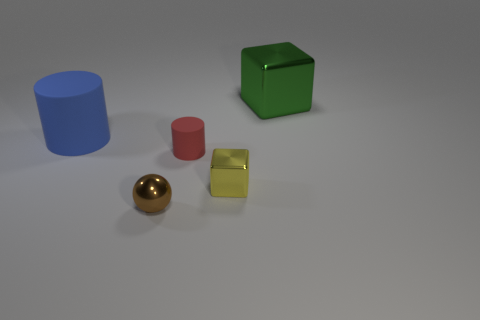There is a small thing that is the same shape as the large metallic thing; what color is it?
Offer a terse response. Yellow. What color is the metal block that is the same size as the red cylinder?
Your answer should be compact. Yellow. Are there an equal number of green blocks in front of the tiny block and tiny brown metallic spheres that are left of the tiny brown metallic thing?
Ensure brevity in your answer.  Yes. How many brown spheres have the same size as the red object?
Your answer should be very brief. 1. How many green objects are metallic objects or cubes?
Provide a succinct answer. 1. Is the number of large green objects that are behind the large green metallic cube the same as the number of cubes?
Ensure brevity in your answer.  No. How big is the matte cylinder that is behind the small red rubber object?
Keep it short and to the point. Large. What number of red metallic objects have the same shape as the large green thing?
Provide a short and direct response. 0. What material is the thing that is behind the tiny red matte cylinder and on the left side of the big green object?
Provide a succinct answer. Rubber. Is the small brown ball made of the same material as the tiny yellow object?
Your answer should be compact. Yes. 